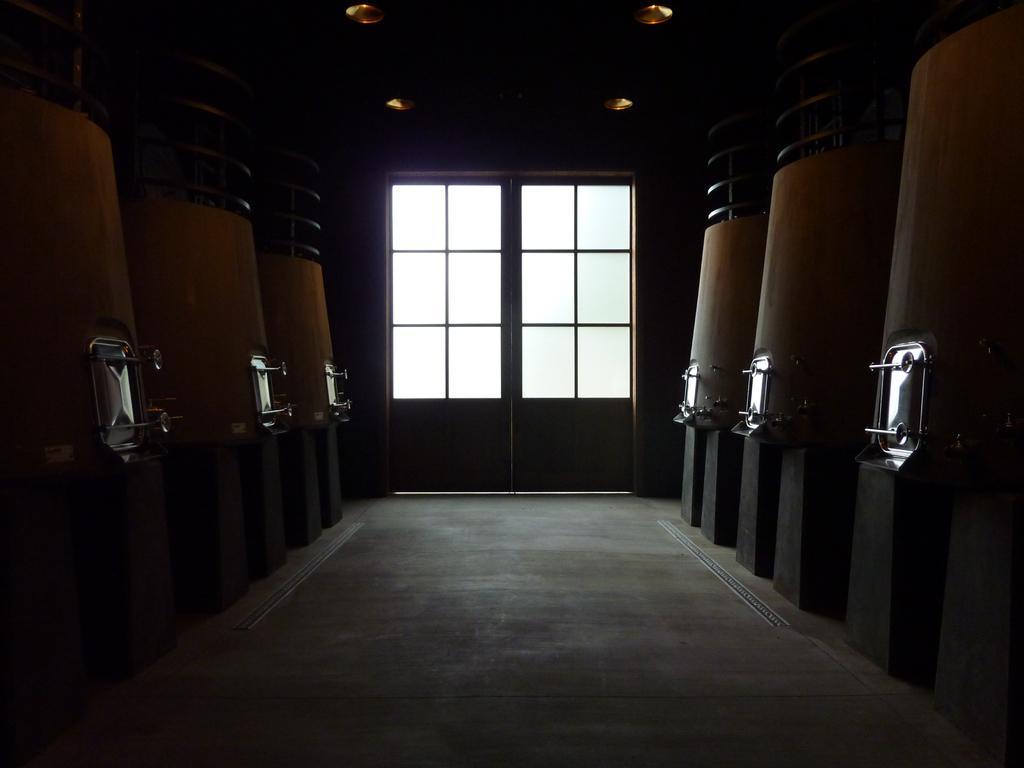Describe this image in one or two sentences. In this image we can see inside of a building. There are few objects at the either sides of the image. We can see the doors of the building. There are few objects at the top of the image. 